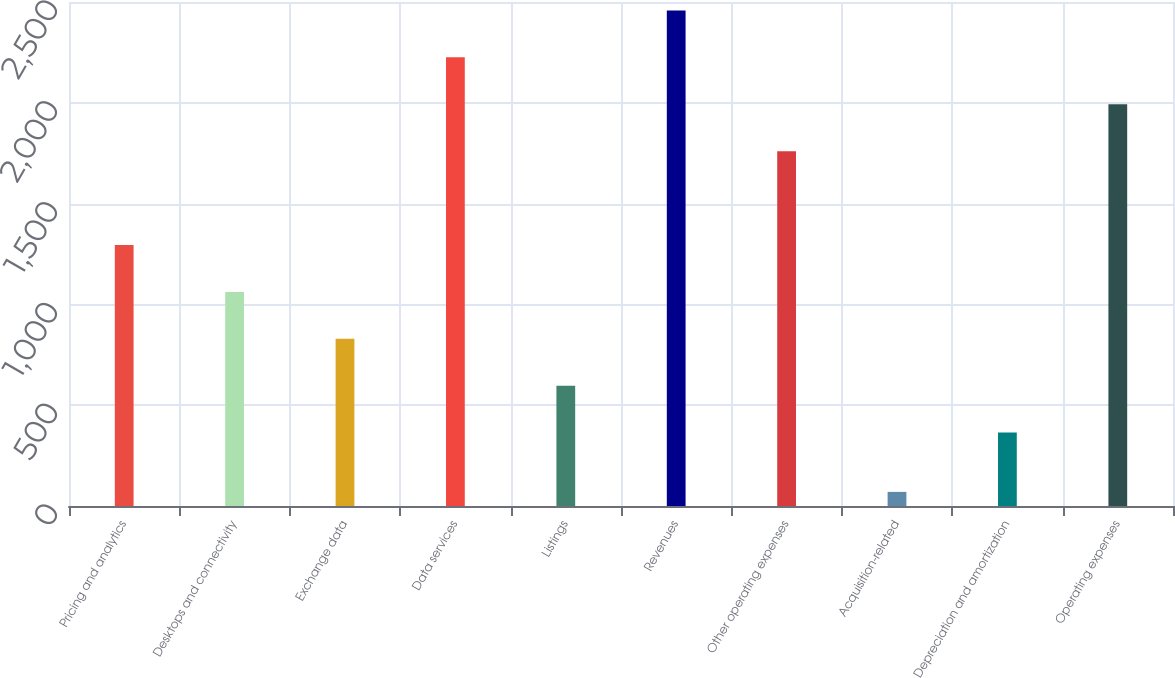<chart> <loc_0><loc_0><loc_500><loc_500><bar_chart><fcel>Pricing and analytics<fcel>Desktops and connectivity<fcel>Exchange data<fcel>Data services<fcel>Listings<fcel>Revenues<fcel>Other operating expenses<fcel>Acquisition-related<fcel>Depreciation and amortization<fcel>Operating expenses<nl><fcel>1294.8<fcel>1062.1<fcel>829.4<fcel>2225.6<fcel>596.7<fcel>2458.3<fcel>1760.2<fcel>70<fcel>364<fcel>1992.9<nl></chart> 